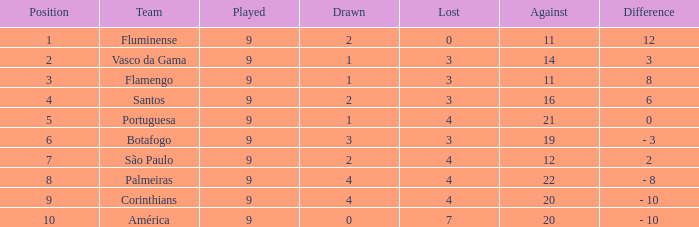Which lost is the highest one possessing a drawn below 4, and a played below 9? None. 